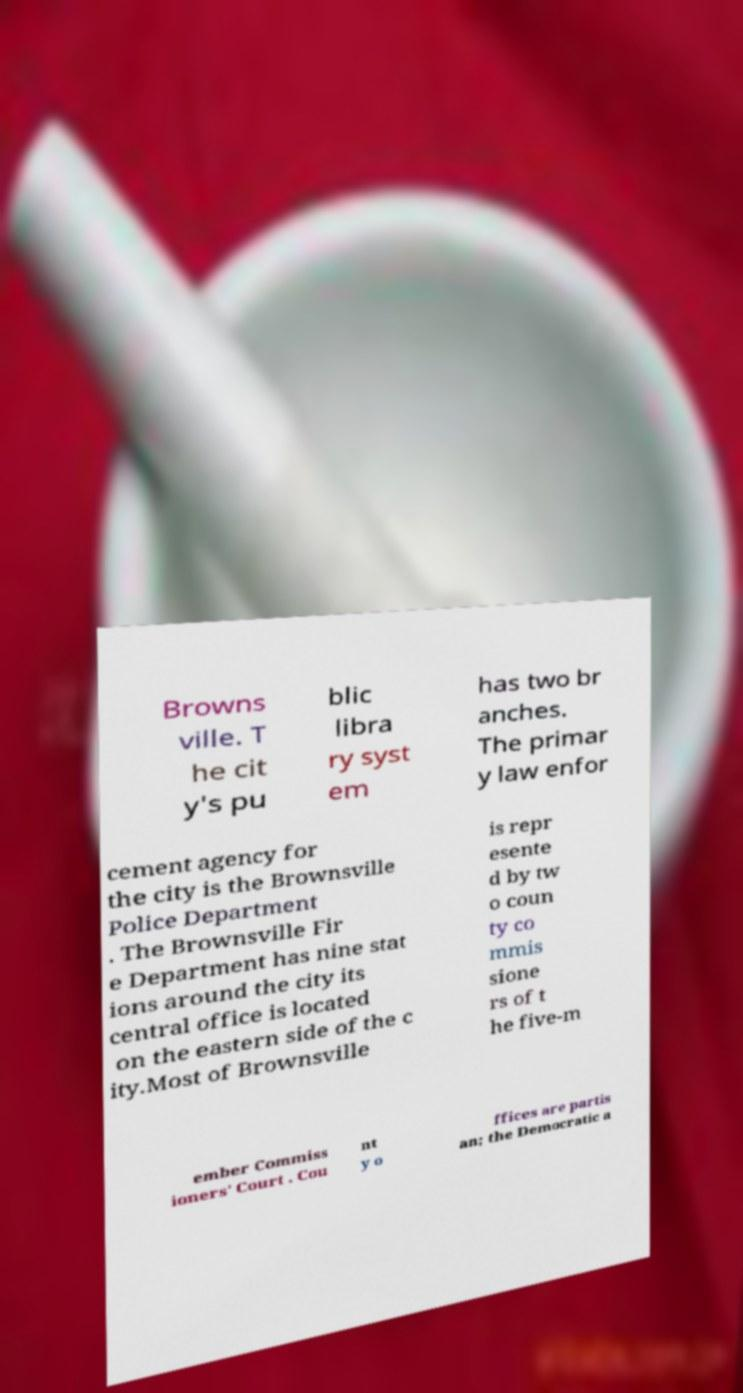Could you assist in decoding the text presented in this image and type it out clearly? Browns ville. T he cit y's pu blic libra ry syst em has two br anches. The primar y law enfor cement agency for the city is the Brownsville Police Department . The Brownsville Fir e Department has nine stat ions around the city its central office is located on the eastern side of the c ity.Most of Brownsville is repr esente d by tw o coun ty co mmis sione rs of t he five-m ember Commiss ioners' Court . Cou nt y o ffices are partis an; the Democratic a 